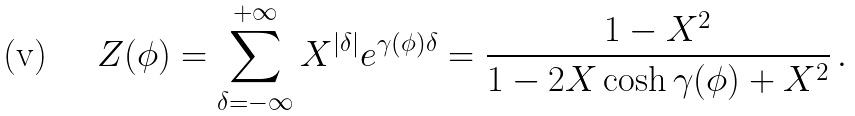<formula> <loc_0><loc_0><loc_500><loc_500>Z ( \phi ) = \sum _ { \delta = - \infty } ^ { + \infty } X ^ { | \delta | } e ^ { \gamma ( \phi ) \delta } = \frac { 1 - X ^ { 2 } } { 1 - 2 X \cosh \gamma ( \phi ) + X ^ { 2 } } \, .</formula> 